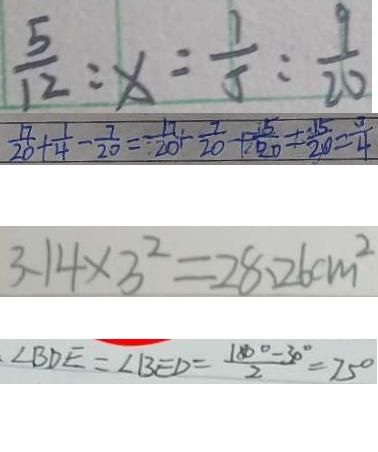Convert formula to latex. <formula><loc_0><loc_0><loc_500><loc_500>\frac { 5 } { 1 2 } : x = \frac { 1 } { 5 } : \frac { 9 } { 2 0 } 
 \frac { 1 7 } { 2 0 } + \frac { 1 } { 4 } - \frac { 7 } { 2 0 } = \frac { 1 7 } { 2 0 } + \frac { 7 } { 2 0 } + \frac { 5 } { 2 0 } = \frac { 1 5 } { 2 0 } = \frac { 3 } { 4 } 
 3 . 1 4 \times 3 ^ { 2 } = 2 8 . 2 6 c m ^ { 2 } 
 \angle B D E = \angle B E D = \frac { 1 8 0 ^ { \circ } - 3 0 ^ { \circ } } { 2 } = 7 5 ^ { \circ }</formula> 